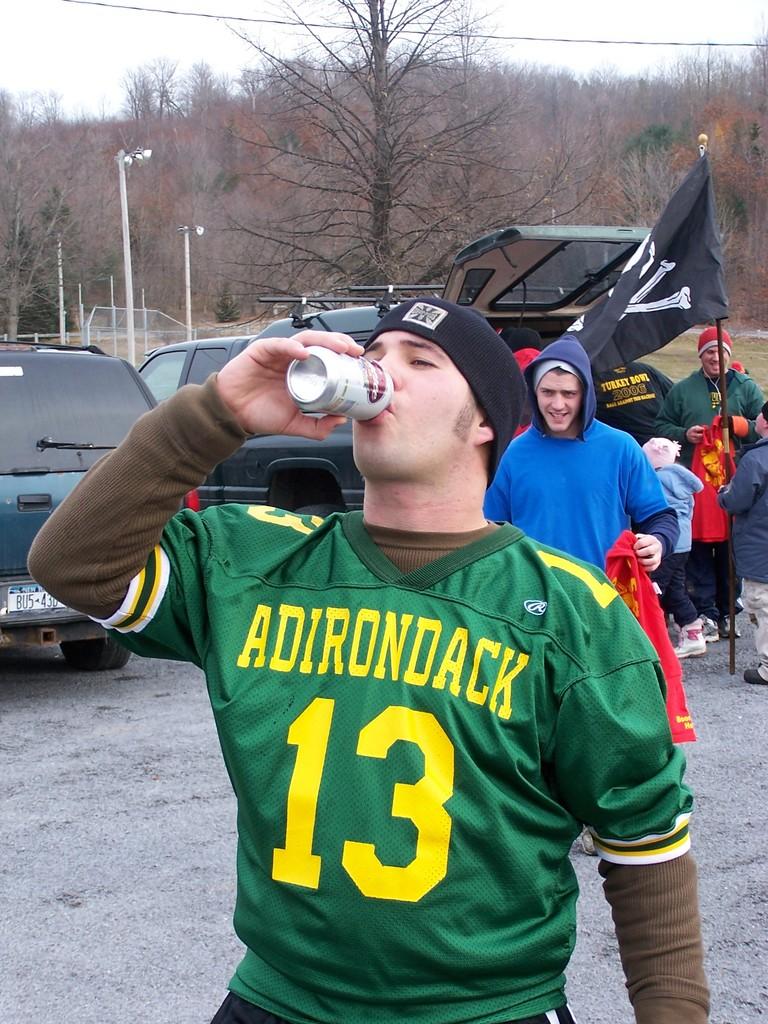What number is this jersey?
Make the answer very short. 13. 